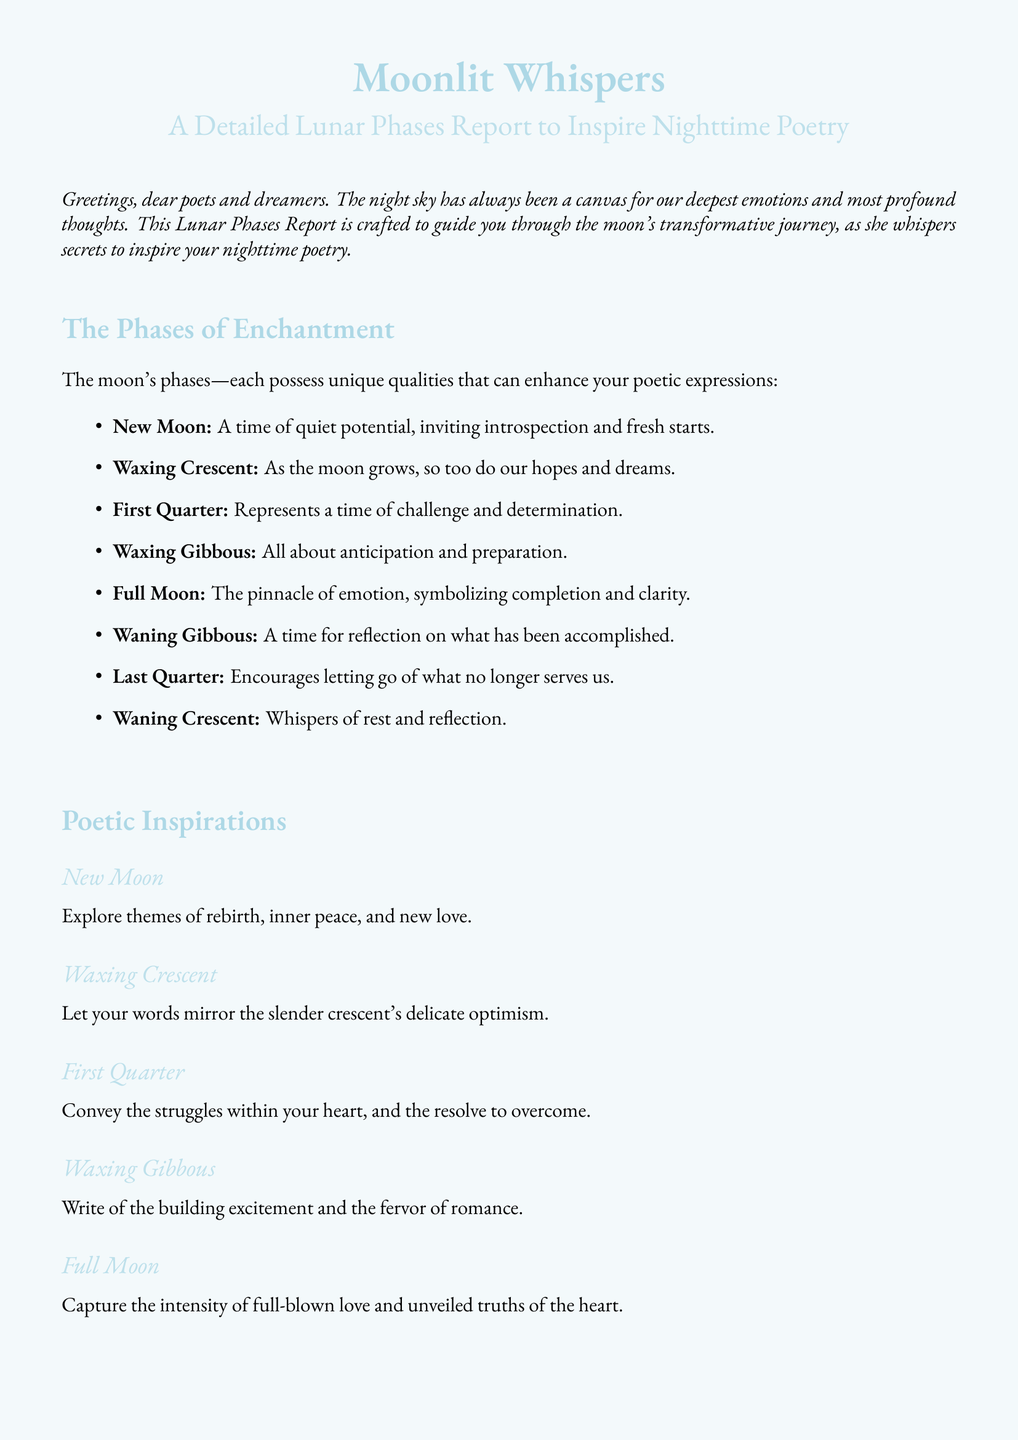What is the title of the document? The title is clearly stated at the beginning of the document.
Answer: Moonlit Whispers How many lunar phases are discussed? The document lists and details each lunar phase in an itemized format.
Answer: Eight What does the New Moon symbolize? The document describes the qualities each lunar phase embodies, including the New Moon.
Answer: Quiet potential What is written about the Full Moon? The Full Moon's section provides specific themes to inspire poetry.
Answer: Intensity of full-blown love What themes are associated with the Last Quarter? The document outlines the connections between lunar phases and poetic themes, particularly for the Last Quarter.
Answer: Release, forgiveness, and transformation Which phase represents anticipation? The document categorizes the phases and their related emotions, and Waxing Gibbous is one such phase.
Answer: Waxing Gibbous What does the document encourage poets to reflect on during the Waning Gibbous? The document explicitly states what to reflect on during this phase.
Answer: Accomplished What is the mood associated with the Waxing Crescent? The Waxing Crescent's themes are explicitly mentioned in the document.
Answer: Delicate optimism 